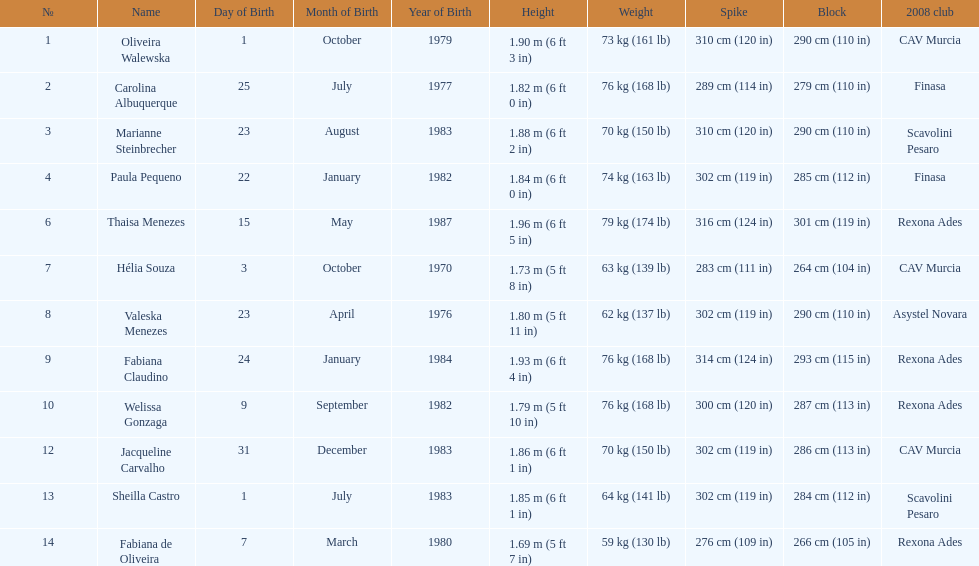Oliveira walewska has the same block as how many other players? 2. 